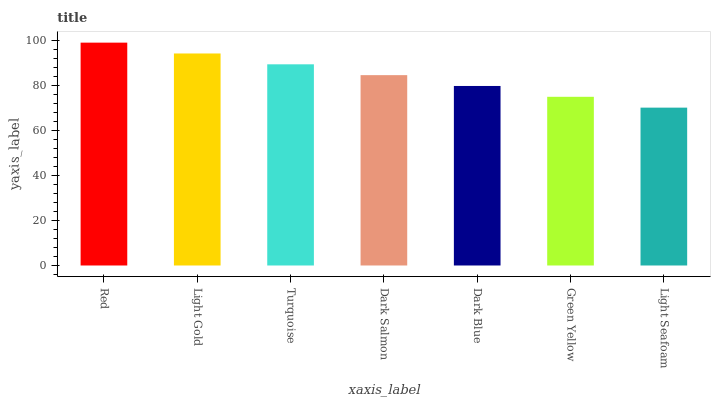Is Light Seafoam the minimum?
Answer yes or no. Yes. Is Red the maximum?
Answer yes or no. Yes. Is Light Gold the minimum?
Answer yes or no. No. Is Light Gold the maximum?
Answer yes or no. No. Is Red greater than Light Gold?
Answer yes or no. Yes. Is Light Gold less than Red?
Answer yes or no. Yes. Is Light Gold greater than Red?
Answer yes or no. No. Is Red less than Light Gold?
Answer yes or no. No. Is Dark Salmon the high median?
Answer yes or no. Yes. Is Dark Salmon the low median?
Answer yes or no. Yes. Is Red the high median?
Answer yes or no. No. Is Turquoise the low median?
Answer yes or no. No. 